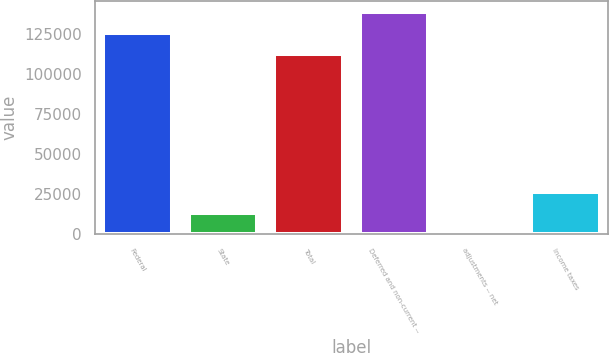<chart> <loc_0><loc_0><loc_500><loc_500><bar_chart><fcel>Federal<fcel>State<fcel>Total<fcel>Deferred and non-current --<fcel>adjustments -- net<fcel>Income taxes<nl><fcel>125911<fcel>13279.6<fcel>112955<fcel>138866<fcel>324<fcel>26235.2<nl></chart> 